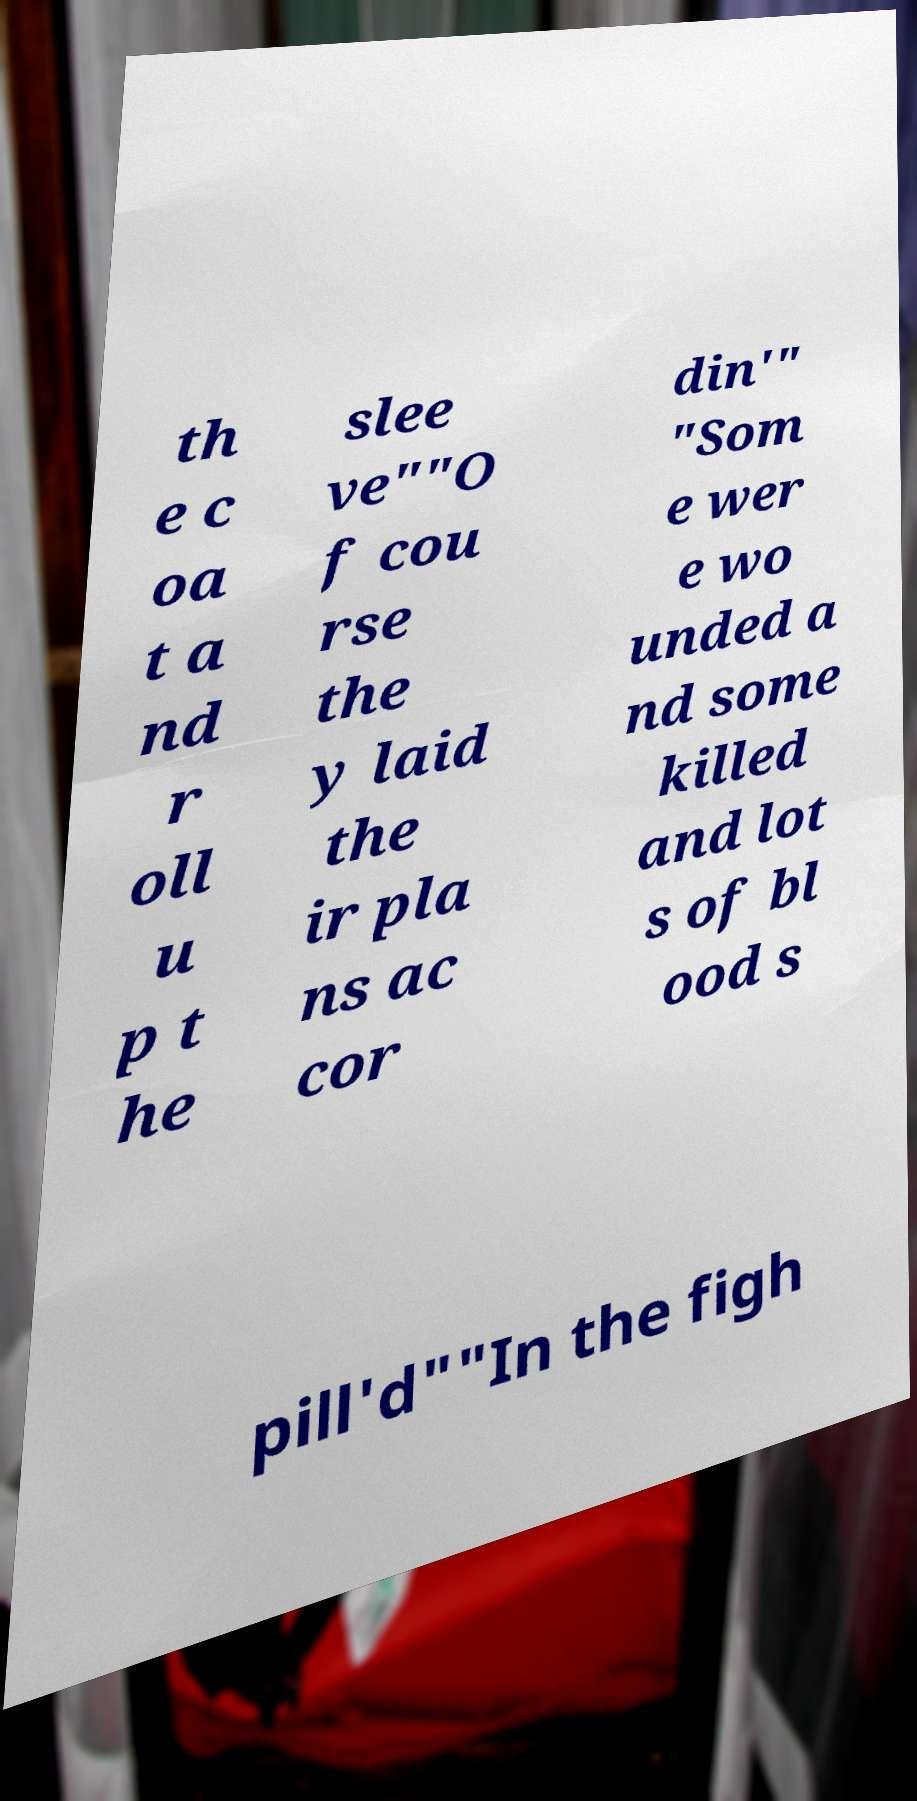Can you read and provide the text displayed in the image?This photo seems to have some interesting text. Can you extract and type it out for me? th e c oa t a nd r oll u p t he slee ve""O f cou rse the y laid the ir pla ns ac cor din'" "Som e wer e wo unded a nd some killed and lot s of bl ood s pill'd""In the figh 